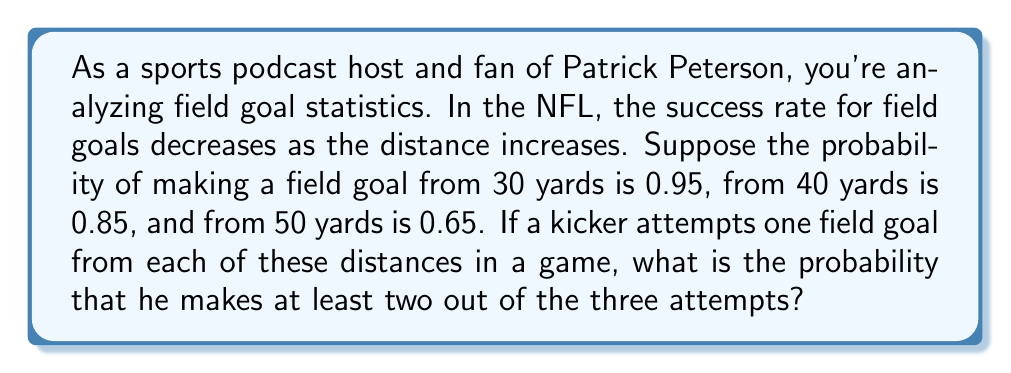Show me your answer to this math problem. To solve this problem, we'll use the concept of complementary events and the multiplication rule of probability.

Let's break it down step-by-step:

1) First, let's define our events:
   $A$: successful 30-yard field goal (probability = 0.95)
   $B$: successful 40-yard field goal (probability = 0.85)
   $C$: successful 50-yard field goal (probability = 0.65)

2) We want the probability of making at least 2 out of 3. It's easier to calculate the probability of making less than 2 (i.e., 0 or 1) and subtract from 1.

3) Probability of making 0:
   $P(\text{none}) = (1-0.95)(1-0.85)(1-0.65) = 0.05 \times 0.15 \times 0.35 = 0.002625$

4) Probability of making exactly 1:
   $P(\text{only A}) = 0.95 \times 0.15 \times 0.35 = 0.049875$
   $P(\text{only B}) = 0.05 \times 0.85 \times 0.35 = 0.014875$
   $P(\text{only C}) = 0.05 \times 0.15 \times 0.65 = 0.004875$

   $P(\text{exactly one}) = 0.049875 + 0.014875 + 0.004875 = 0.069625$

5) Probability of making less than 2 = $P(\text{none}) + P(\text{exactly one}) = 0.002625 + 0.069625 = 0.07225$

6) Therefore, the probability of making at least 2 is:
   $P(\text{at least 2}) = 1 - P(\text{less than 2}) = 1 - 0.07225 = 0.92775$
Answer: The probability that the kicker makes at least two out of the three field goal attempts is approximately 0.92775 or about 92.78%. 